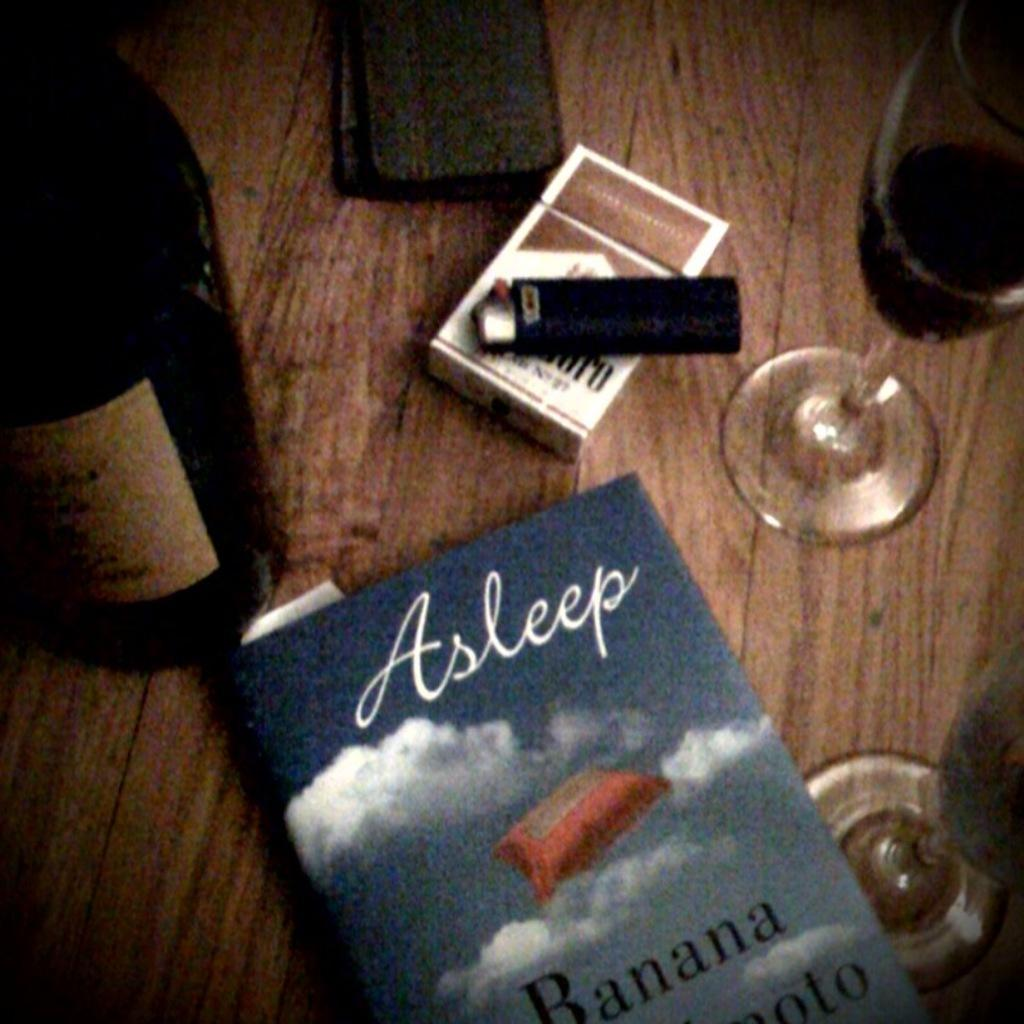<image>
Present a compact description of the photo's key features. table contains Marlboro cigarettes, wine, a wallet and the book Asleep. 